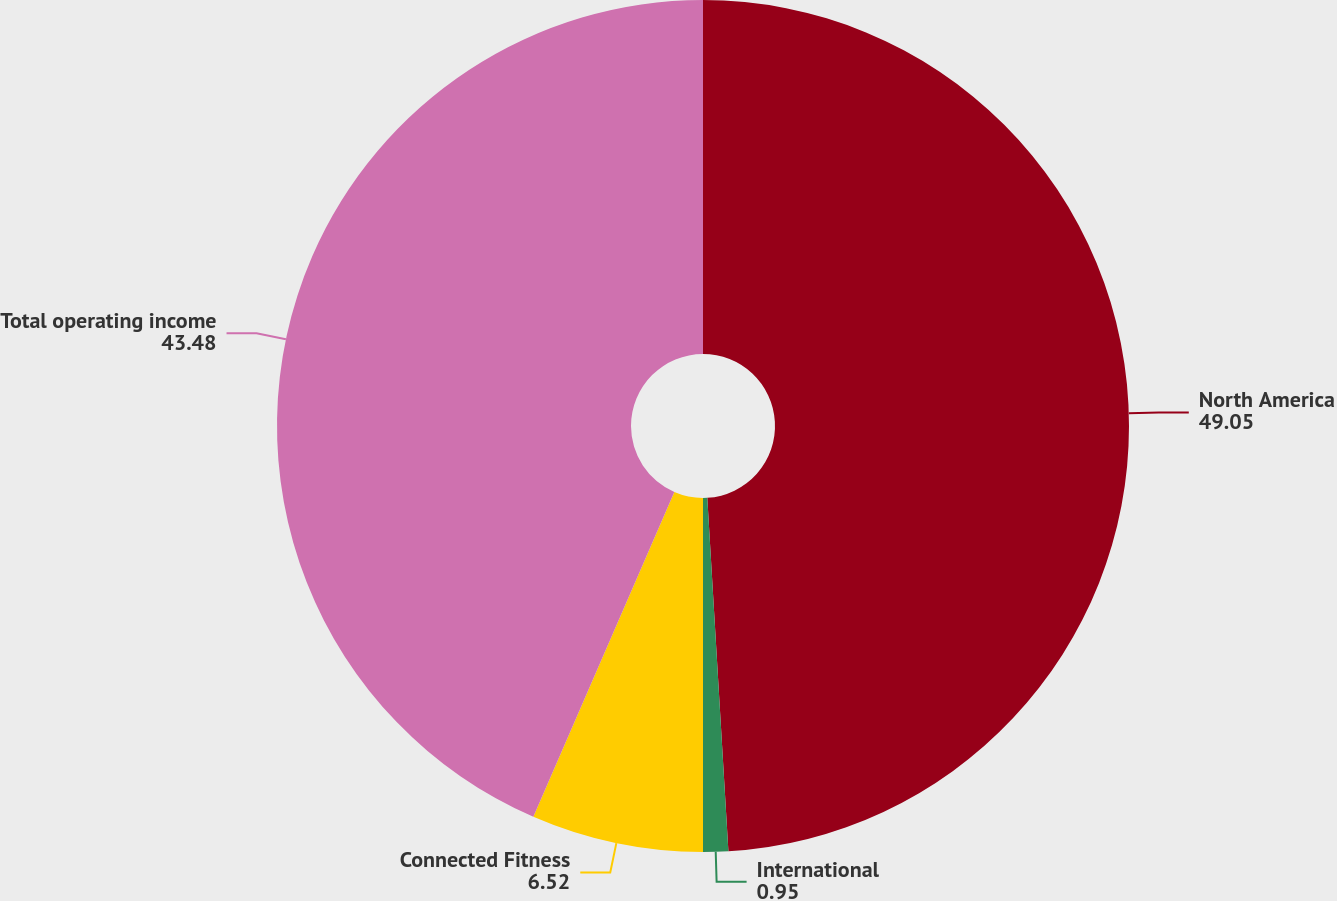<chart> <loc_0><loc_0><loc_500><loc_500><pie_chart><fcel>North America<fcel>International<fcel>Connected Fitness<fcel>Total operating income<nl><fcel>49.05%<fcel>0.95%<fcel>6.52%<fcel>43.48%<nl></chart> 